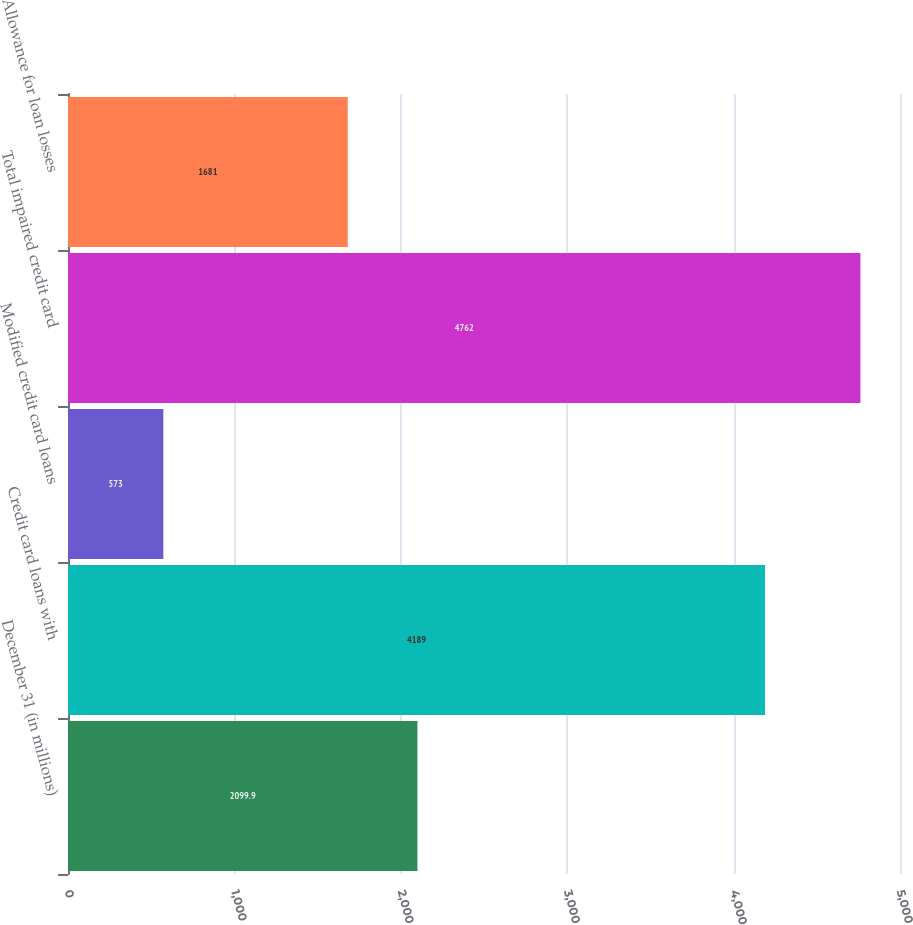Convert chart to OTSL. <chart><loc_0><loc_0><loc_500><loc_500><bar_chart><fcel>December 31 (in millions)<fcel>Credit card loans with<fcel>Modified credit card loans<fcel>Total impaired credit card<fcel>Allowance for loan losses<nl><fcel>2099.9<fcel>4189<fcel>573<fcel>4762<fcel>1681<nl></chart> 